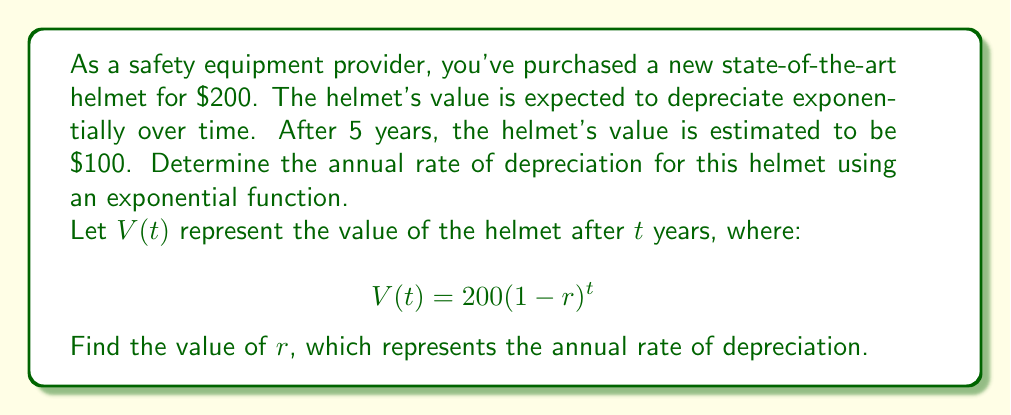Solve this math problem. To solve this problem, we'll use the exponential decay function and the given information:

1. Initial value: $V(0) = 200$
2. Value after 5 years: $V(5) = 100$
3. Exponential decay function: $V(t) = 200(1-r)^t$

Let's solve for $r$:

1. Substitute the known values into the equation:
   $$100 = 200(1-r)^5$$

2. Divide both sides by 200:
   $$\frac{1}{2} = (1-r)^5$$

3. Take the fifth root of both sides:
   $$\sqrt[5]{\frac{1}{2}} = 1-r$$

4. Simplify the left side:
   $$0.8705 \approx 1-r$$

5. Subtract both sides from 1:
   $$1 - 0.8705 \approx r$$

6. Solve for $r$:
   $$r \approx 0.1295$$

Therefore, the annual rate of depreciation is approximately 0.1295 or 12.95%.
Answer: $r \approx 0.1295$ or 12.95% 